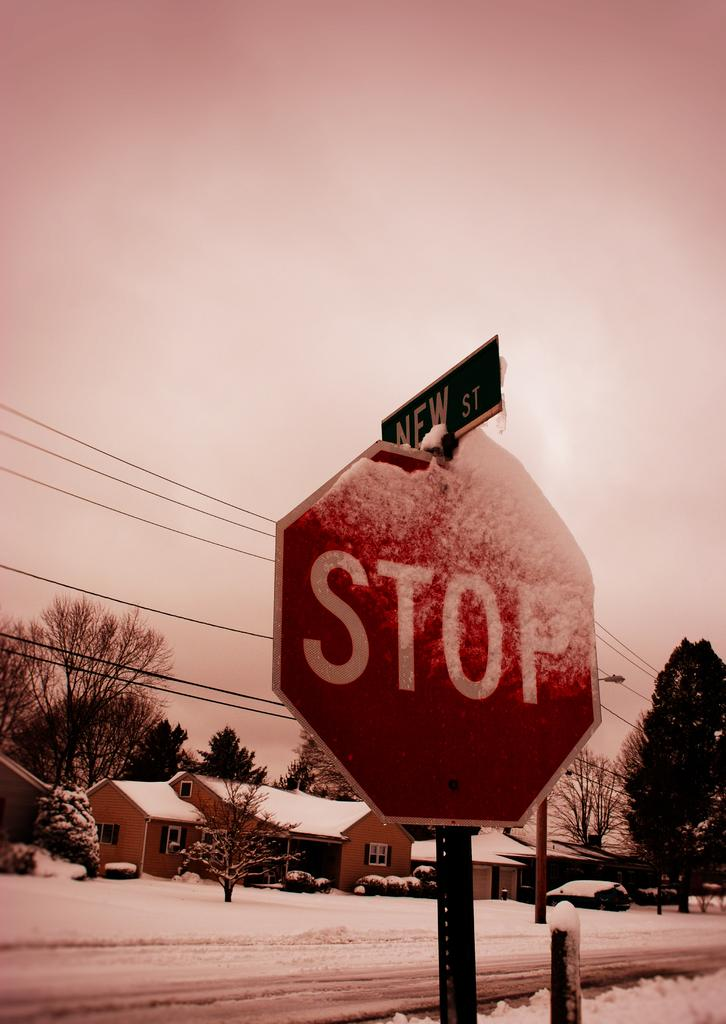<image>
Give a short and clear explanation of the subsequent image. A stop sign on New Street after a recent snowstorm. 